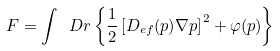<formula> <loc_0><loc_0><loc_500><loc_500>F = \int \ D { r } \left \{ \frac { 1 } { 2 } \left [ D _ { e f } ( p ) \nabla p \right ] ^ { 2 } + \varphi ( p ) \right \}</formula> 